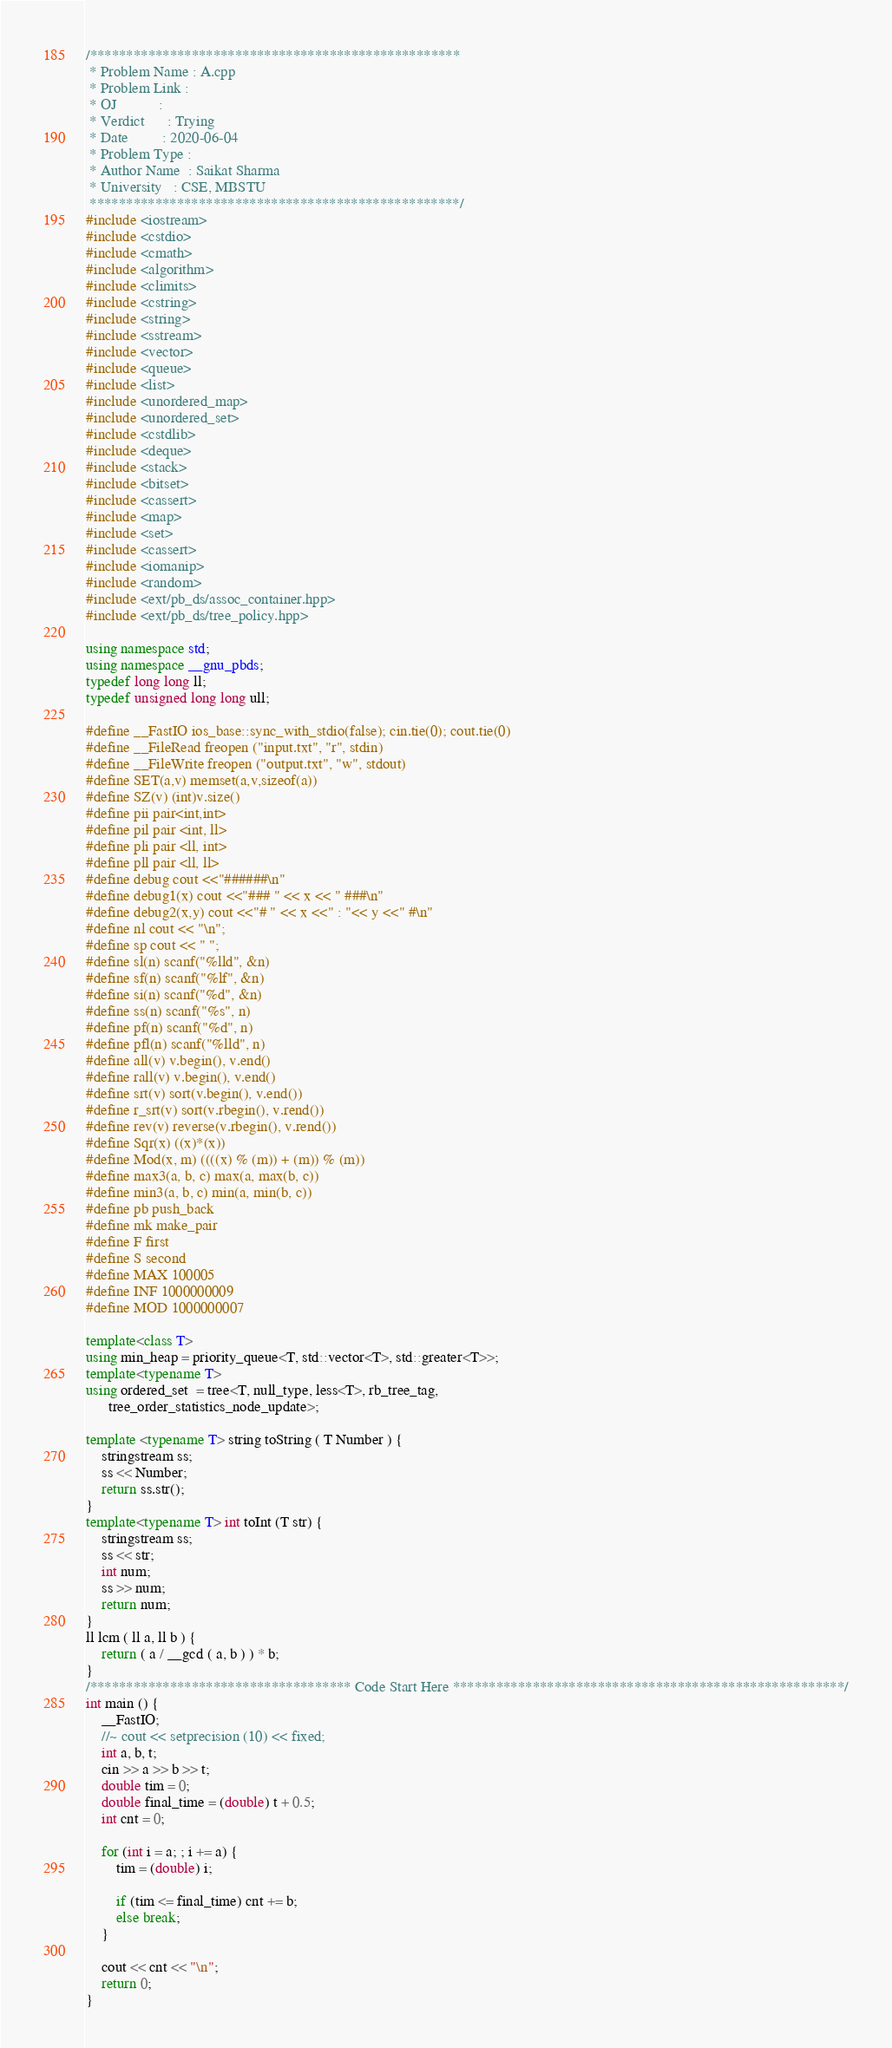<code> <loc_0><loc_0><loc_500><loc_500><_C++_>/***************************************************
 * Problem Name : A.cpp
 * Problem Link :
 * OJ           :
 * Verdict      : Trying
 * Date         : 2020-06-04
 * Problem Type :
 * Author Name  : Saikat Sharma
 * University   : CSE, MBSTU
 ***************************************************/
#include <iostream>
#include <cstdio>
#include <cmath>
#include <algorithm>
#include <climits>
#include <cstring>
#include <string>
#include <sstream>
#include <vector>
#include <queue>
#include <list>
#include <unordered_map>
#include <unordered_set>
#include <cstdlib>
#include <deque>
#include <stack>
#include <bitset>
#include <cassert>
#include <map>
#include <set>
#include <cassert>
#include <iomanip>
#include <random>
#include <ext/pb_ds/assoc_container.hpp>
#include <ext/pb_ds/tree_policy.hpp>

using namespace std;
using namespace __gnu_pbds;
typedef long long ll;
typedef unsigned long long ull;

#define __FastIO ios_base::sync_with_stdio(false); cin.tie(0); cout.tie(0)
#define __FileRead freopen ("input.txt", "r", stdin)
#define __FileWrite freopen ("output.txt", "w", stdout)
#define SET(a,v) memset(a,v,sizeof(a))
#define SZ(v) (int)v.size()
#define pii pair<int,int>
#define pil pair <int, ll>
#define pli pair <ll, int>
#define pll pair <ll, ll>
#define debug cout <<"######\n"
#define debug1(x) cout <<"### " << x << " ###\n"
#define debug2(x,y) cout <<"# " << x <<" : "<< y <<" #\n"
#define nl cout << "\n";
#define sp cout << " ";
#define sl(n) scanf("%lld", &n)
#define sf(n) scanf("%lf", &n)
#define si(n) scanf("%d", &n)
#define ss(n) scanf("%s", n)
#define pf(n) scanf("%d", n)
#define pfl(n) scanf("%lld", n)
#define all(v) v.begin(), v.end()
#define rall(v) v.begin(), v.end()
#define srt(v) sort(v.begin(), v.end())
#define r_srt(v) sort(v.rbegin(), v.rend())
#define rev(v) reverse(v.rbegin(), v.rend())
#define Sqr(x) ((x)*(x))
#define Mod(x, m) ((((x) % (m)) + (m)) % (m))
#define max3(a, b, c) max(a, max(b, c))
#define min3(a, b, c) min(a, min(b, c))
#define pb push_back
#define mk make_pair
#define F first
#define S second
#define MAX 100005
#define INF 1000000009
#define MOD 1000000007

template<class T>
using min_heap = priority_queue<T, std::vector<T>, std::greater<T>>;
template<typename T>
using ordered_set  = tree<T, null_type, less<T>, rb_tree_tag,
      tree_order_statistics_node_update>;

template <typename T> string toString ( T Number ) {
    stringstream ss;
    ss << Number;
    return ss.str();
}
template<typename T> int toInt (T str) {
    stringstream ss;
    ss << str;
    int num;
    ss >> num;
    return num;
}
ll lcm ( ll a, ll b ) {
    return ( a / __gcd ( a, b ) ) * b;
}
/************************************ Code Start Here ******************************************************/
int main () {
    __FastIO;
    //~ cout << setprecision (10) << fixed;
    int a, b, t;
    cin >> a >> b >> t;
    double tim = 0;
    double final_time = (double) t + 0.5;
    int cnt = 0;

    for (int i = a; ; i += a) {
        tim = (double) i;

        if (tim <= final_time) cnt += b;
        else break;
    }

    cout << cnt << "\n";
    return 0;
}
</code> 